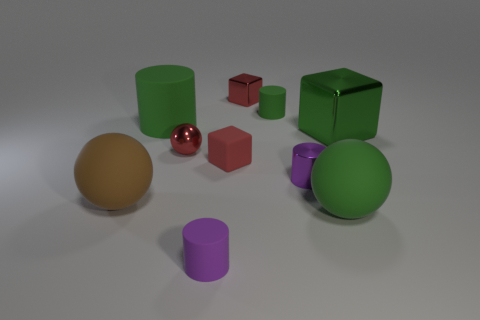What number of other things are there of the same shape as the purple metallic thing?
Provide a short and direct response. 3. There is a tiny sphere that is the same color as the tiny rubber block; what material is it?
Offer a very short reply. Metal. How many other small balls have the same color as the tiny metallic ball?
Your answer should be very brief. 0. What is the color of the block that is made of the same material as the big brown sphere?
Ensure brevity in your answer.  Red. Is there a green metallic thing of the same size as the purple metal cylinder?
Your response must be concise. No. Are there more rubber cubes that are in front of the purple rubber object than red cubes behind the metallic ball?
Keep it short and to the point. No. Does the green cylinder that is in front of the tiny green matte thing have the same material as the green object that is in front of the large green shiny cube?
Your answer should be compact. Yes. What is the shape of the red rubber object that is the same size as the metallic cylinder?
Your answer should be very brief. Cube. Are there any small gray things that have the same shape as the tiny green rubber thing?
Give a very brief answer. No. There is a tiny metal thing in front of the small red metal sphere; is its color the same as the large sphere on the left side of the small purple matte thing?
Ensure brevity in your answer.  No. 